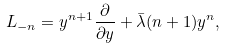<formula> <loc_0><loc_0><loc_500><loc_500>L _ { - n } = y ^ { n + 1 } \frac { \partial } { \partial y } + \bar { \lambda } ( n + 1 ) y ^ { n } ,</formula> 